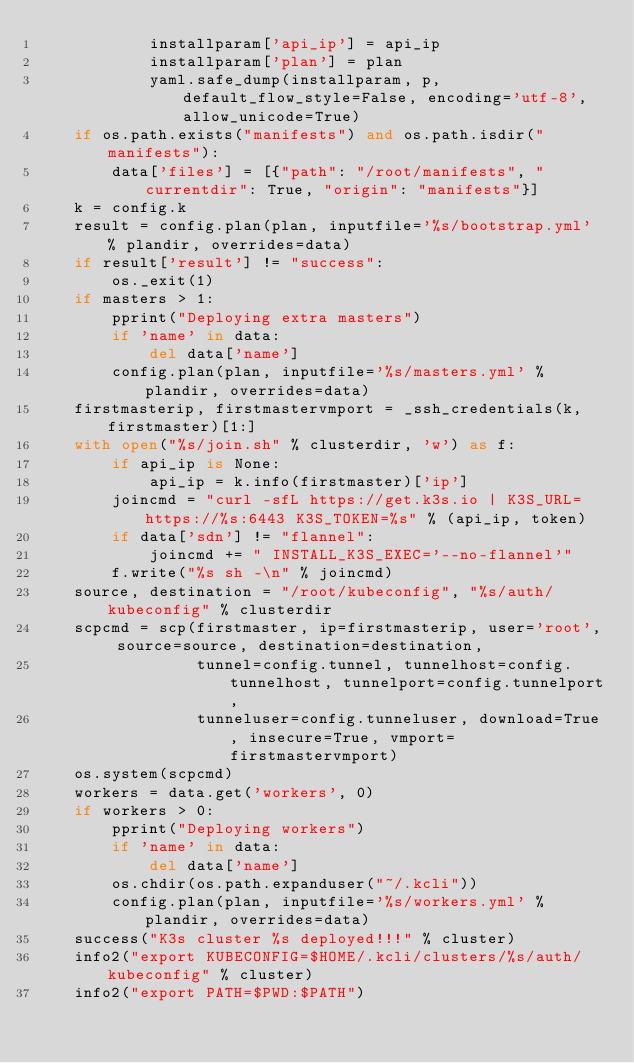<code> <loc_0><loc_0><loc_500><loc_500><_Python_>            installparam['api_ip'] = api_ip
            installparam['plan'] = plan
            yaml.safe_dump(installparam, p, default_flow_style=False, encoding='utf-8', allow_unicode=True)
    if os.path.exists("manifests") and os.path.isdir("manifests"):
        data['files'] = [{"path": "/root/manifests", "currentdir": True, "origin": "manifests"}]
    k = config.k
    result = config.plan(plan, inputfile='%s/bootstrap.yml' % plandir, overrides=data)
    if result['result'] != "success":
        os._exit(1)
    if masters > 1:
        pprint("Deploying extra masters")
        if 'name' in data:
            del data['name']
        config.plan(plan, inputfile='%s/masters.yml' % plandir, overrides=data)
    firstmasterip, firstmastervmport = _ssh_credentials(k, firstmaster)[1:]
    with open("%s/join.sh" % clusterdir, 'w') as f:
        if api_ip is None:
            api_ip = k.info(firstmaster)['ip']
        joincmd = "curl -sfL https://get.k3s.io | K3S_URL=https://%s:6443 K3S_TOKEN=%s" % (api_ip, token)
        if data['sdn'] != "flannel":
            joincmd += " INSTALL_K3S_EXEC='--no-flannel'"
        f.write("%s sh -\n" % joincmd)
    source, destination = "/root/kubeconfig", "%s/auth/kubeconfig" % clusterdir
    scpcmd = scp(firstmaster, ip=firstmasterip, user='root', source=source, destination=destination,
                 tunnel=config.tunnel, tunnelhost=config.tunnelhost, tunnelport=config.tunnelport,
                 tunneluser=config.tunneluser, download=True, insecure=True, vmport=firstmastervmport)
    os.system(scpcmd)
    workers = data.get('workers', 0)
    if workers > 0:
        pprint("Deploying workers")
        if 'name' in data:
            del data['name']
        os.chdir(os.path.expanduser("~/.kcli"))
        config.plan(plan, inputfile='%s/workers.yml' % plandir, overrides=data)
    success("K3s cluster %s deployed!!!" % cluster)
    info2("export KUBECONFIG=$HOME/.kcli/clusters/%s/auth/kubeconfig" % cluster)
    info2("export PATH=$PWD:$PATH")
</code> 